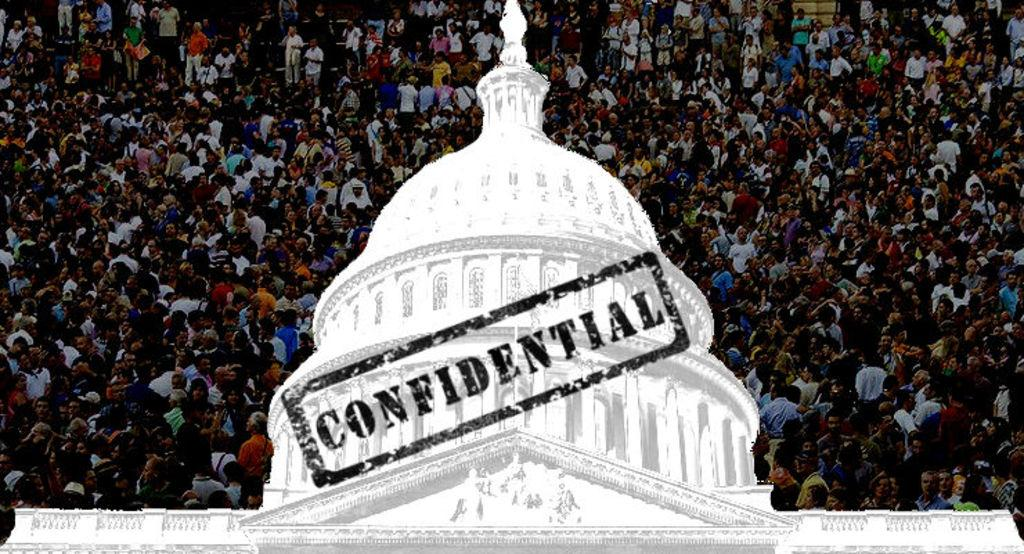What is the main subject of the image? The main subject of the image is a crowd. Can you describe any structures or objects in the image? Yes, there is a building in the image. What is the purpose of the confidential stamp in the image? The purpose of the confidential stamp in the image is to indicate that the information or document it is placed on is confidential. What type of carpenter is working on the land in the image? There is no carpenter or land present in the image. What religious symbols can be seen in the image? There are no religious symbols present in the image. 